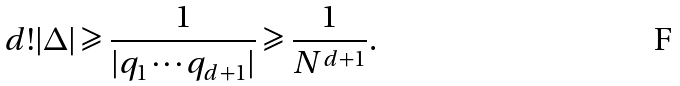Convert formula to latex. <formula><loc_0><loc_0><loc_500><loc_500>d ! | \Delta | \geqslant \frac { 1 } { | q _ { 1 } \cdots q _ { d + 1 } | } \geqslant \frac { 1 } { N ^ { d + 1 } } .</formula> 